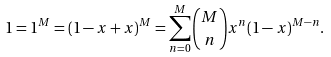Convert formula to latex. <formula><loc_0><loc_0><loc_500><loc_500>1 = 1 ^ { M } = ( 1 - x + x ) ^ { M } = \sum _ { n = 0 } ^ { M } { M \choose n } x ^ { n } ( 1 - x ) ^ { M - n } .</formula> 